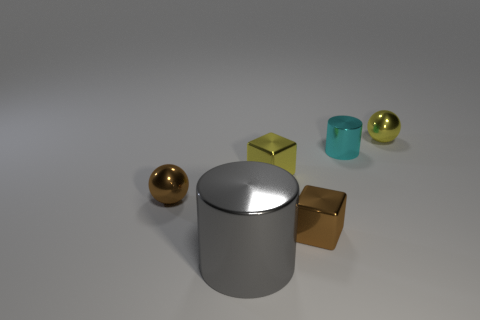Add 2 tiny objects. How many objects exist? 8 Subtract all brown blocks. How many blocks are left? 1 Subtract 1 cubes. How many cubes are left? 1 Subtract all balls. How many objects are left? 4 Subtract all gray cylinders. Subtract all tiny shiny balls. How many objects are left? 3 Add 3 objects. How many objects are left? 9 Add 6 small yellow shiny balls. How many small yellow shiny balls exist? 7 Subtract 0 blue spheres. How many objects are left? 6 Subtract all gray cylinders. Subtract all green balls. How many cylinders are left? 1 